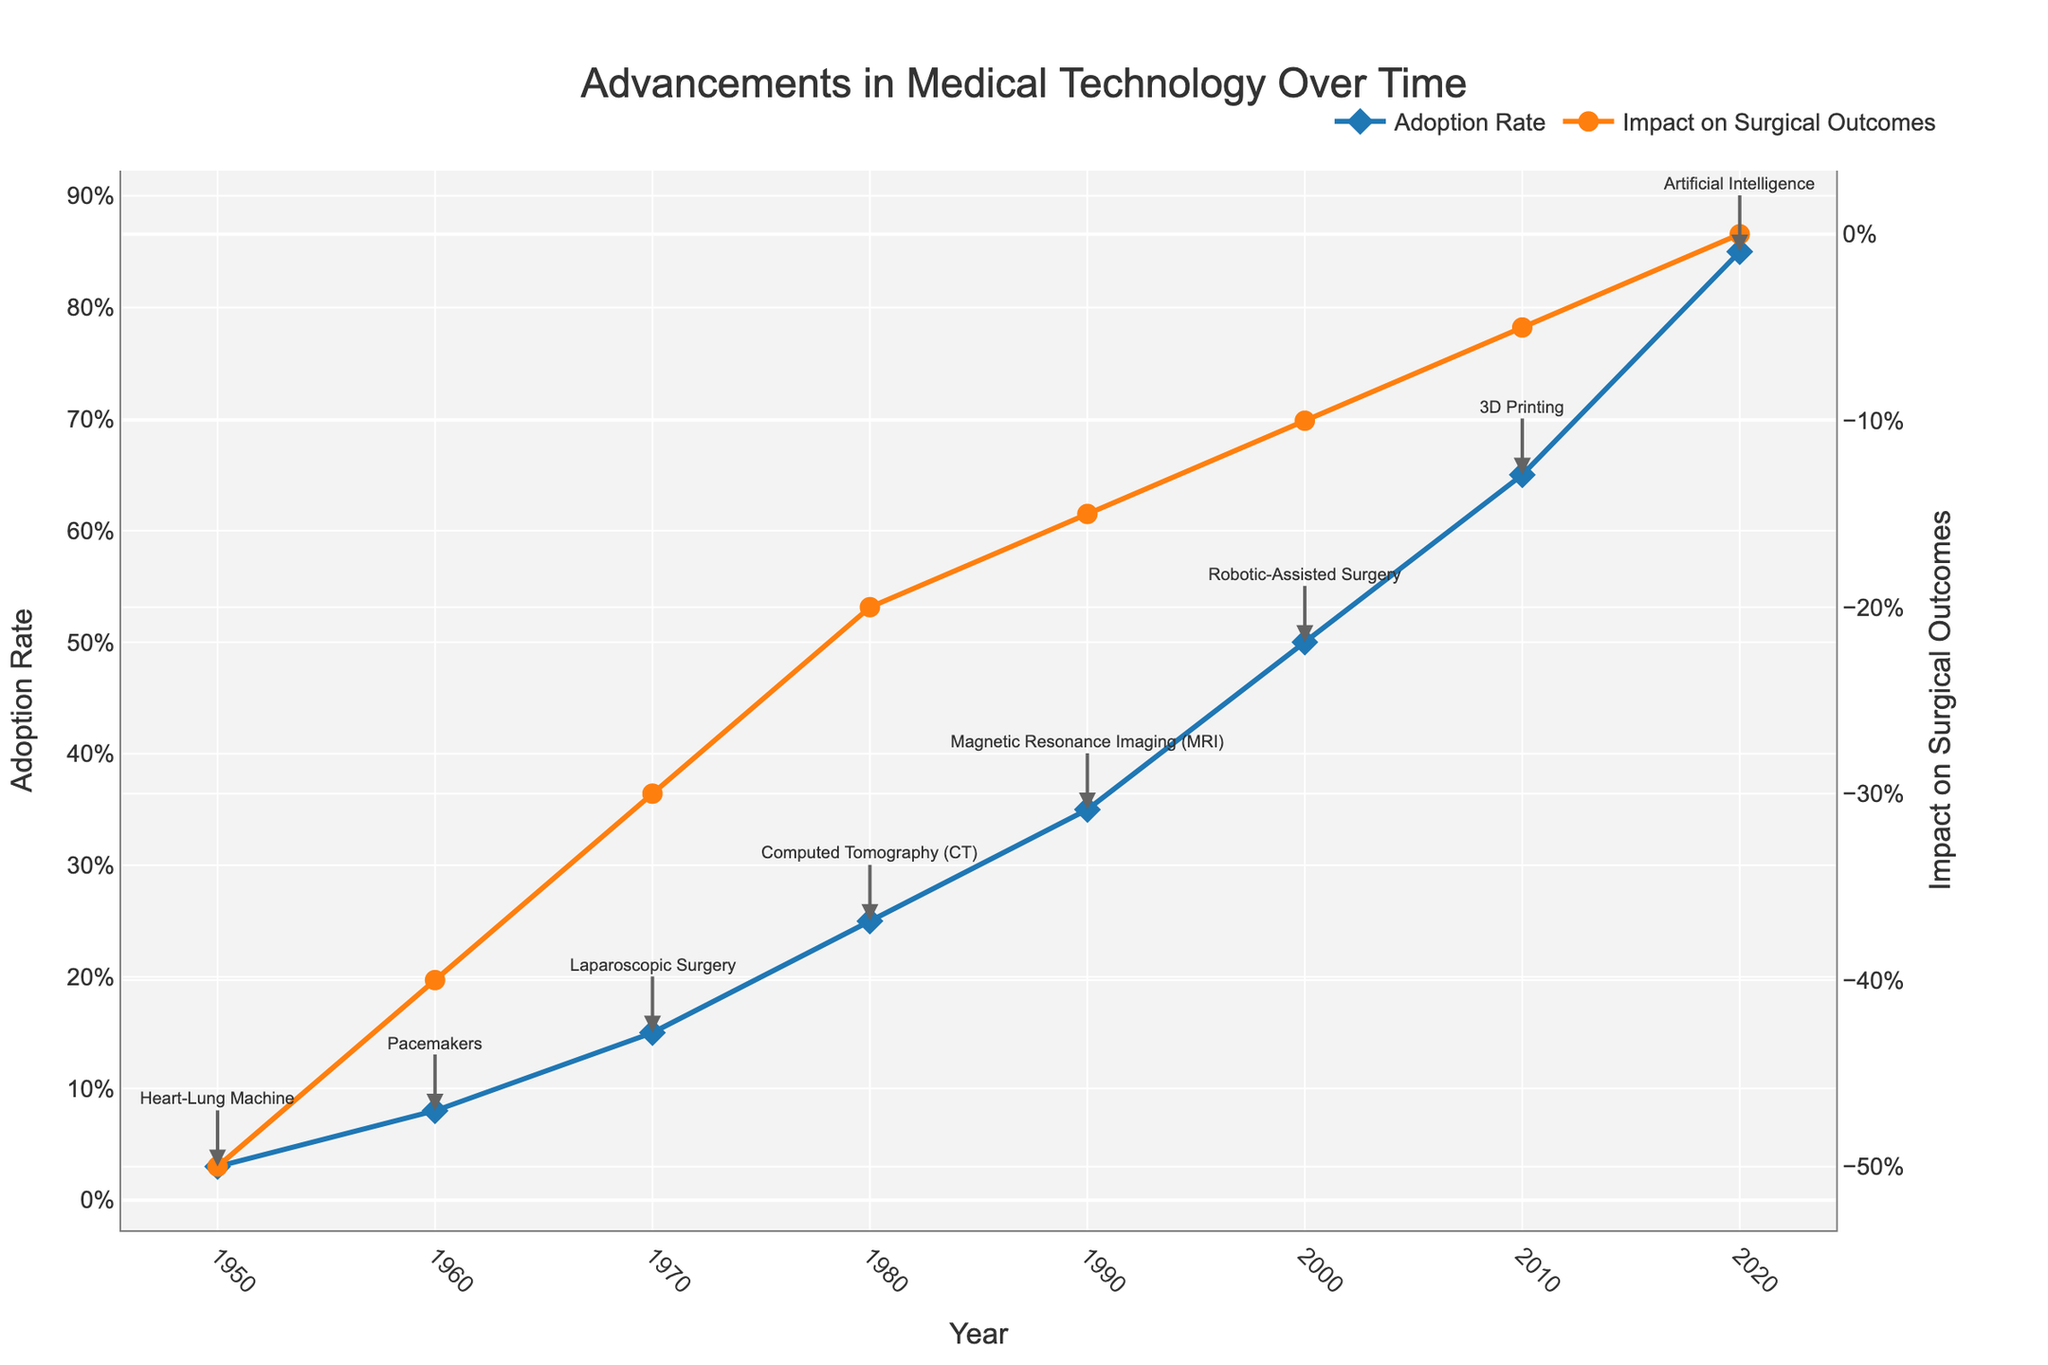What is the title of the plot? The title is displayed prominently at the top of the figure. It reads "Advancements in Medical Technology Over Time," which indicates it is about the progression of medical technology and its effects.
Answer: Advancements in Medical Technology Over Time How does the Adoption Rate change over time? The Adoption Rate is represented by the blue line and diamond markers. It increases steadily over time, starting from 3% in 1950 to 85% in 2020.
Answer: It increases steadily What was the Adoption Rate of 3D Printing in 2010? Locate the blue line and diamond marker for the year 2010 and note the y-axis value. The Adoption Rate for 3D Printing in 2010 was 65%.
Answer: 65% Which technology had the highest positive impact on surgical outcomes? The impact is represented by the orange line and circle markers. The highest positive impact (closest to 0%) can be seen for Artificial Intelligence in 2020, which has an impact of 0%.
Answer: Artificial Intelligence Compare the Adoption Rate of Pacemakers in 1960 to Robotic-Assisted Surgery in 2000. Locate the blue line and diamond markers for 1960 and 2000. In 1960, Pacemakers had an Adoption Rate of 8%, while in 2000, Robotic-Assisted Surgery had 50%. The Adoption Rate increased by 42%.
Answer: Robotic-Assisted Surgery had a higher rate by 42% What is the average Adoption Rate between 1980 and 2000? Identify the Adoption Rates for the years 1980 (Computed Tomography, 25%), 1990 (Magnetic Resonance Imaging, 35%), and 2000 (Robotic-Assisted Surgery, 50%). Calculate the average: (25% + 35% + 50%) / 3 = 36.67%.
Answer: 36.67% Which technology resulted in a 30% improvement in surgical outcomes? The orange line and circle markers indicate the percentage improvements. 1970's Laparoscopic Surgery is the technology indicating a -30% impact (improvement) on surgical outcomes.
Answer: Laparoscopic Surgery How did the Impact on Surgical Outcomes change from 1990 (MRI) to 2000 (Robotic-Assisted Surgery)? The impact goes from -15% (MRI in 1990) to -10% (Robotic-Assisted Surgery in 2000). Calculate the change: -10% - (-15%) = +5% increase in outcomes effectiveness.
Answer: +5% improvement What was the Adoption Rate of the Heart-Lung Machine in 1950, and how did it impact surgical outcomes? The blue line and diamond marker for 1950 indicate an Adoption Rate of 3%, and the orange line and circle marker indicate a -50% impact on surgical outcomes.
Answer: 3% Adoption Rate, -50% impact Which year saw the introduction of Artificial Intelligence in medical technology, and what was its impact? Locate the blue and orange lines for the year corresponding to Artificial Intelligence. In 2020, Artificial Intelligence was introduced, and it had a 0% impact on surgical outcomes.
Answer: 2020, 0% impact 